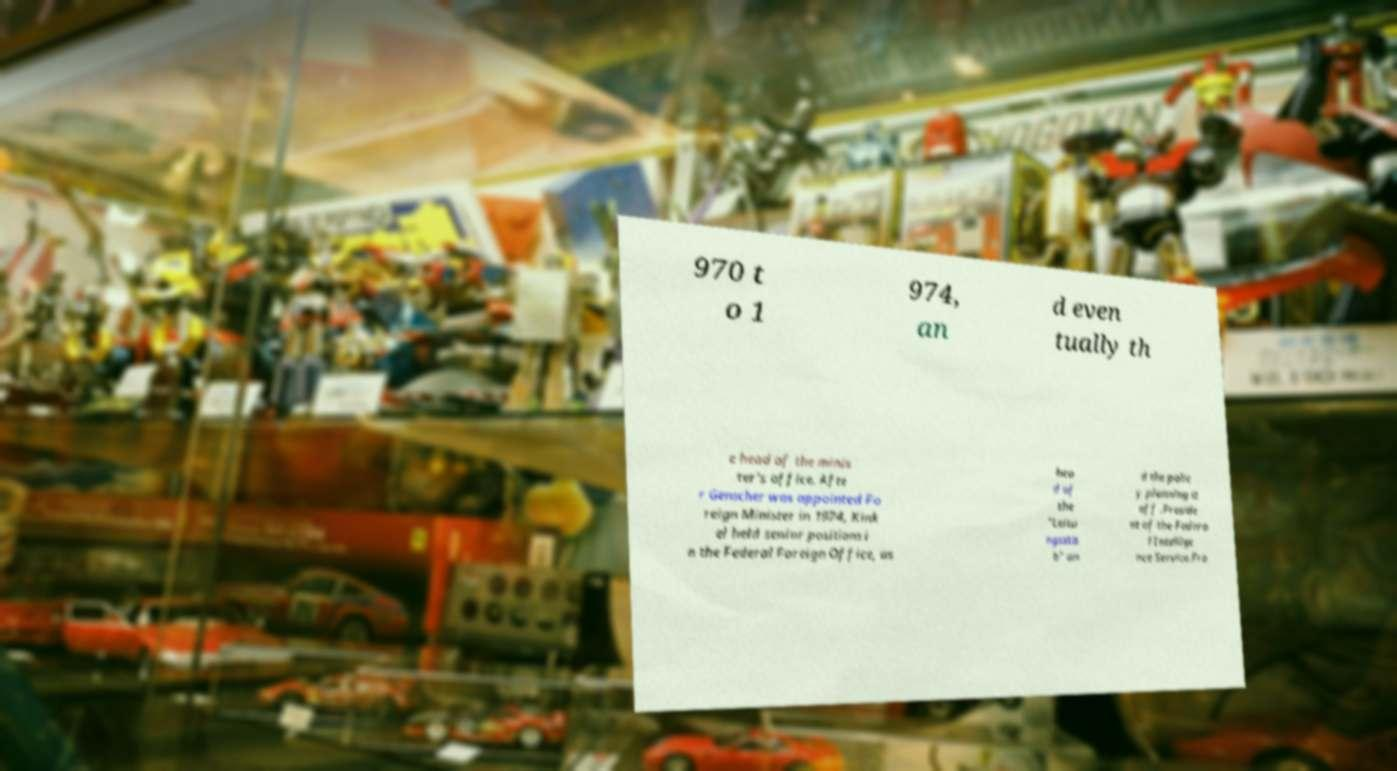Could you extract and type out the text from this image? 970 t o 1 974, an d even tually th e head of the minis ter's office. Afte r Genscher was appointed Fo reign Minister in 1974, Kink el held senior positions i n the Federal Foreign Office, as hea d of the "Leitu ngssta b" an d the polic y planning st aff .Preside nt of the Federa l Intellige nce Service.Fro 